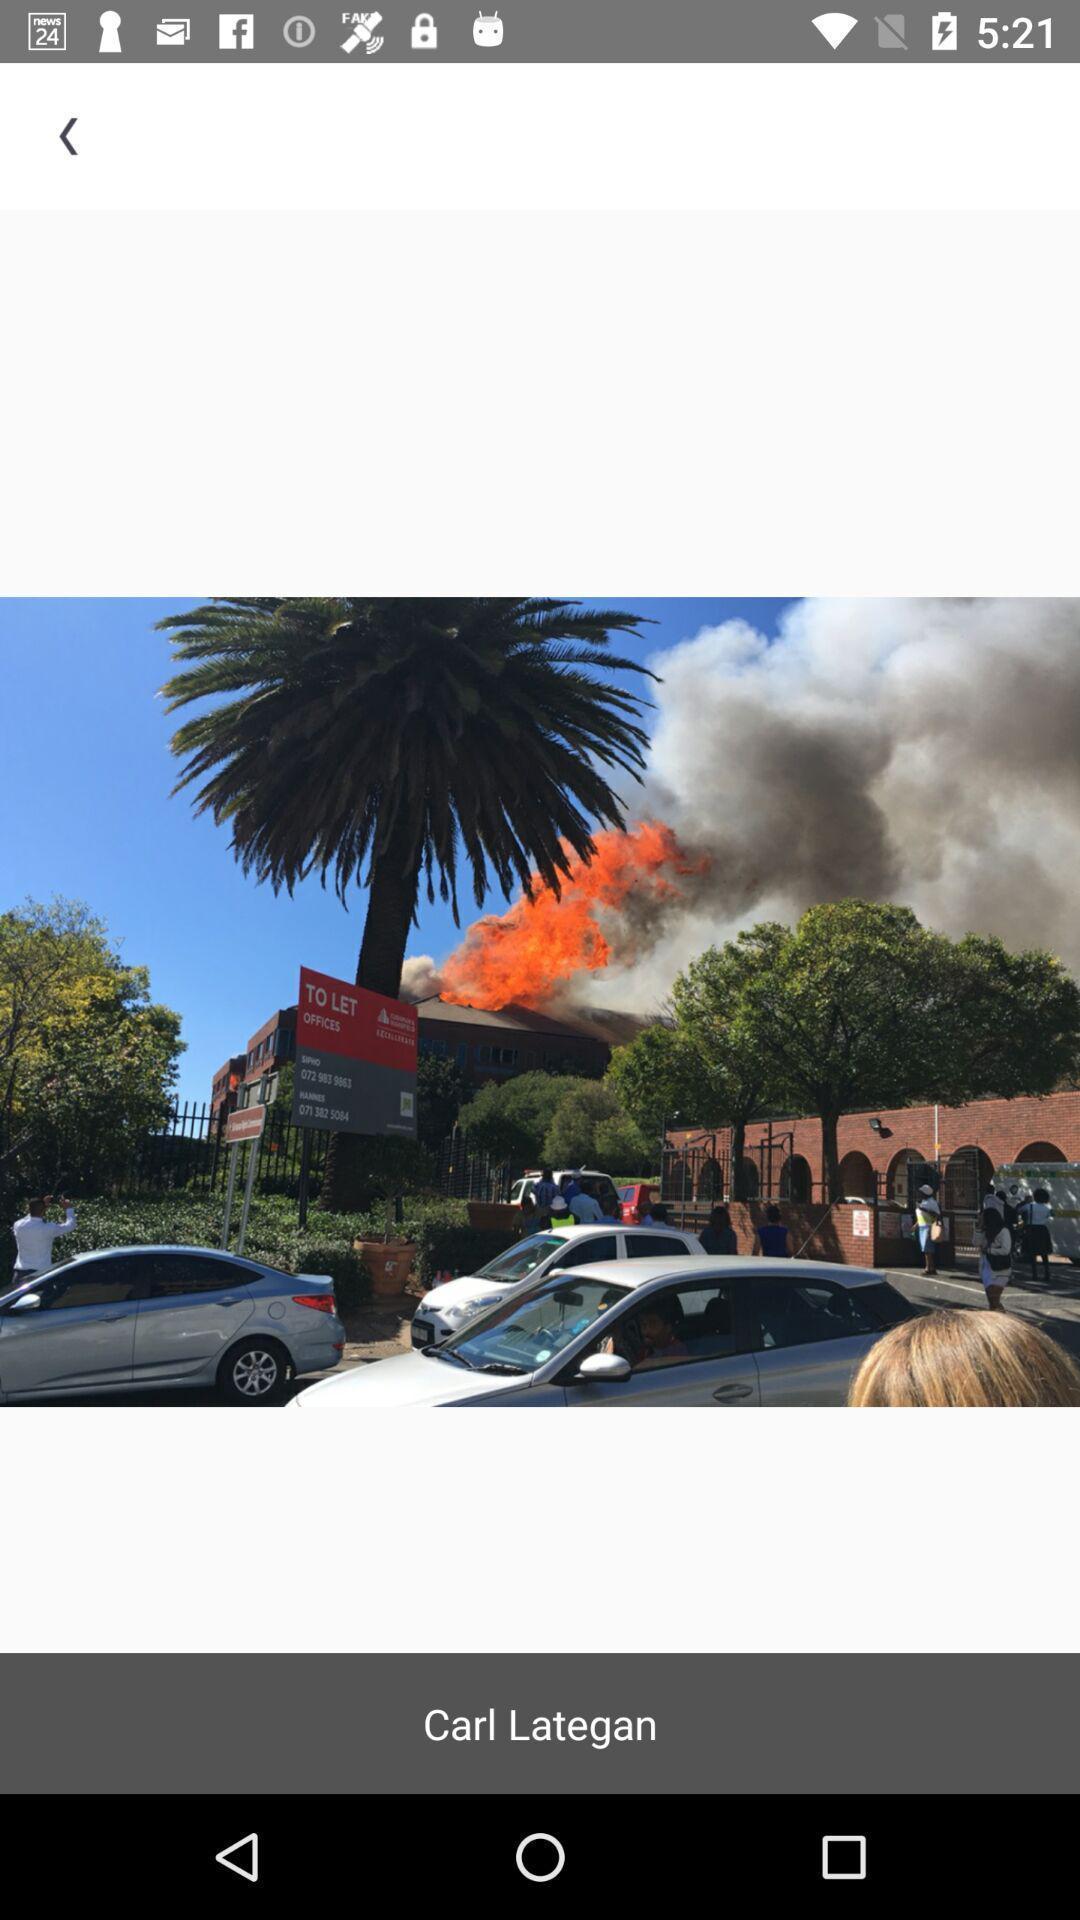Tell me about the visual elements in this screen capture. Picture of a carl lategan. 